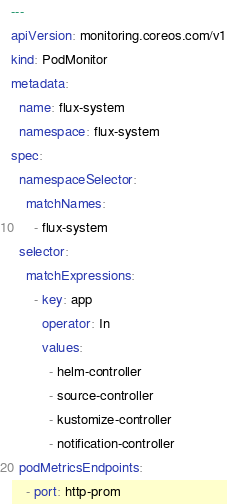<code> <loc_0><loc_0><loc_500><loc_500><_YAML_>---
apiVersion: monitoring.coreos.com/v1
kind: PodMonitor
metadata:
  name: flux-system
  namespace: flux-system
spec:
  namespaceSelector:
    matchNames:
      - flux-system
  selector:
    matchExpressions:
      - key: app
        operator: In
        values:
          - helm-controller
          - source-controller
          - kustomize-controller
          - notification-controller
  podMetricsEndpoints:
    - port: http-prom
</code> 